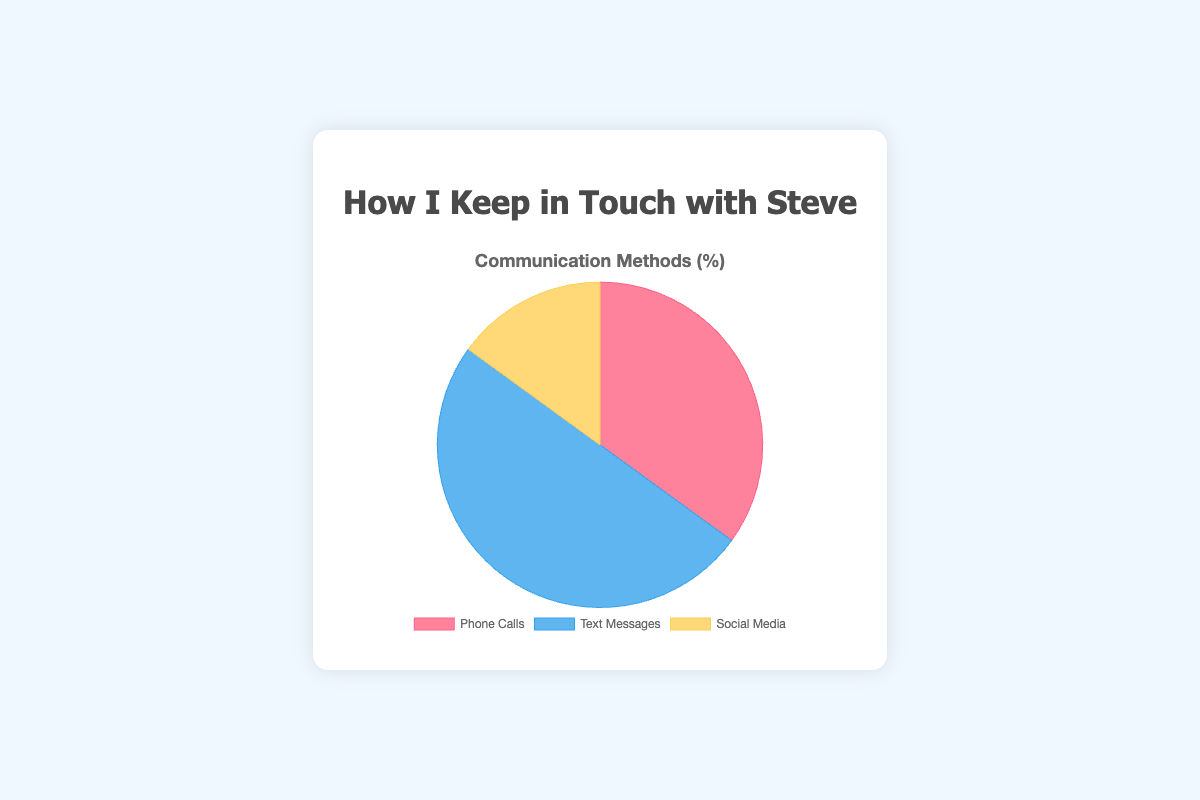What is the most common mode of communication? The sectors in the pie chart show percentages. Text messages have the largest sector at 50%.
Answer: Text messages Which mode of communication is least common? The smallest sector represents the least common mode. The sector for Social Media is the smallest at 15%.
Answer: Social Media How much higher is the percentage of text messages compared to phone calls? Text messages are at 50%, and phone calls are at 35%. The difference is 50% - 35% = 15%.
Answer: 15% What is the sum of the percentages for phone calls and social media? Phone calls are at 35% and social media is at 15%. Adding these together gives 35% + 15% = 50%.
Answer: 50% How does the percentage of phone calls compare to social media in terms of multiple? The percentage of phone calls is 35%, and social media is 15%. To find how many times 15 fits into 35, divide 35 by 15. 35 / 15 ≈ 2.33.
Answer: About 2.33 times What is the color of the sector representing text messages? The sector for text messages is represented by the color blue.
Answer: Blue Which two modes combined equal the percentage for text messages? The percentage for text messages is 50%. Phone calls are 35% and social media is 15%. Adding them together gives 35% + 15% = 50%.
Answer: Phone calls and social media What percentage of the communication is not through text messages? The total percentage for all modes is 100%. The percentage for text messages is 50%. So, communication not through text messages is 100% - 50% = 50%.
Answer: 50% What is the average percentage for all three communication modes? The percentages are 35%, 50%, and 15%. Adding them together gives 35 + 50 + 15 = 100. Dividing by 3 gives 100 / 3 ≈ 33.33%.
Answer: About 33.33% If Steve used text messages 20 times, how many times did he use social media, assuming similar usage patterns? Text messages make up 50% and social media 15%. If text messages are 20 times, we set up the proportion 50 : 20 = 15 : x. Solving for x gives x = 15 * 20 / 50 = 6.
Answer: 6 times 